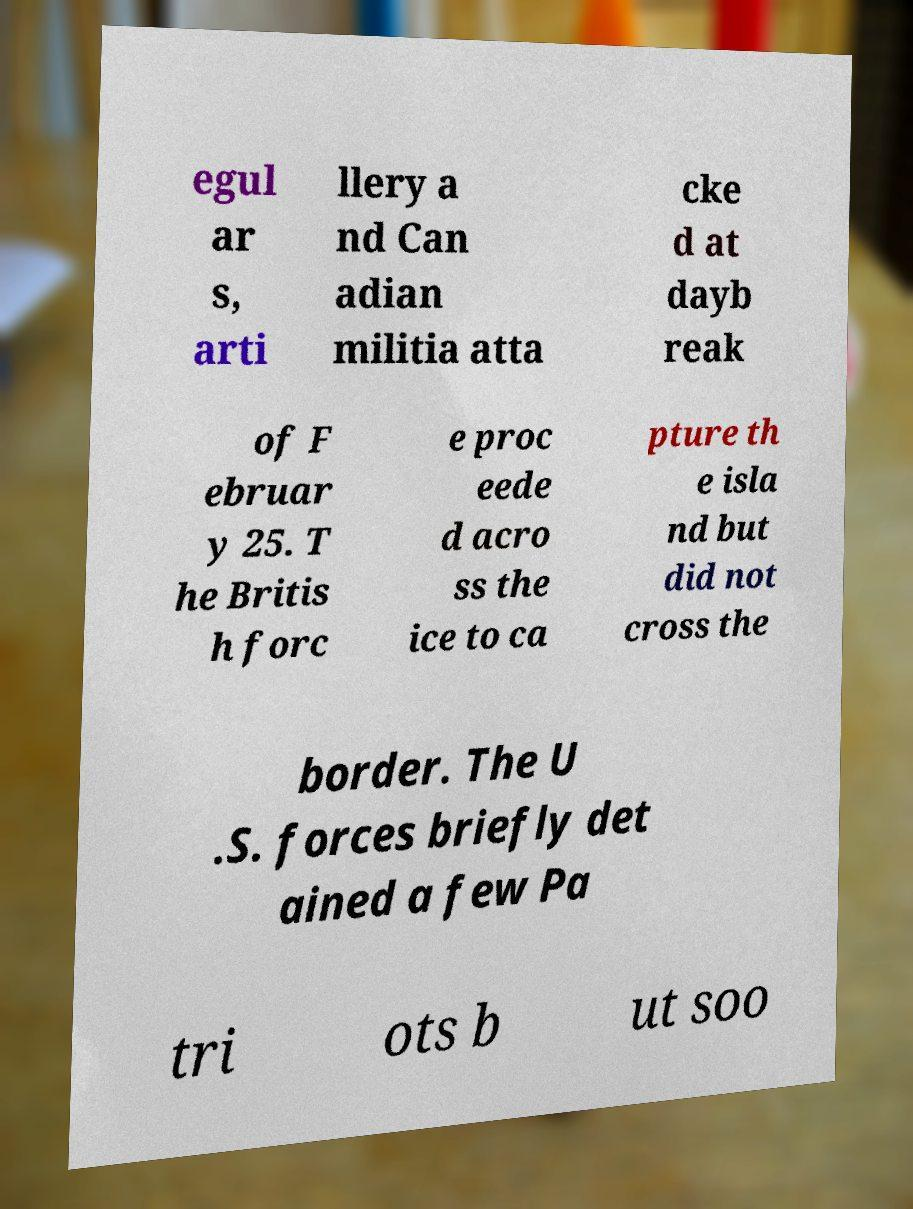Could you extract and type out the text from this image? egul ar s, arti llery a nd Can adian militia atta cke d at dayb reak of F ebruar y 25. T he Britis h forc e proc eede d acro ss the ice to ca pture th e isla nd but did not cross the border. The U .S. forces briefly det ained a few Pa tri ots b ut soo 